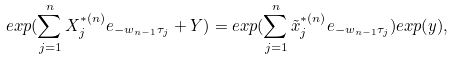<formula> <loc_0><loc_0><loc_500><loc_500>e x p ( \sum _ { j = 1 } ^ { n } X _ { j } ^ { * ( n ) } e _ { - w _ { n - 1 } \tau _ { j } } + Y ) = e x p ( \sum _ { j = 1 } ^ { n } \tilde { x } _ { j } ^ { * ( n ) } e _ { - w _ { n - 1 } \tau _ { j } } ) e x p ( y ) ,</formula> 